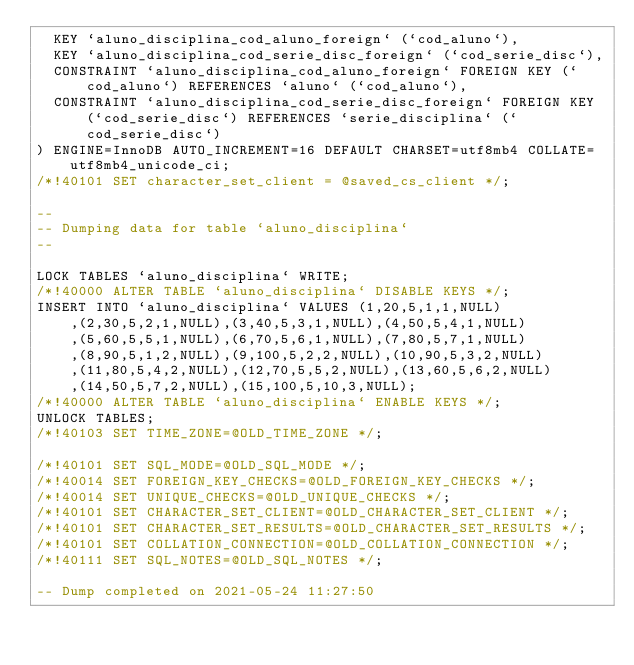<code> <loc_0><loc_0><loc_500><loc_500><_SQL_>  KEY `aluno_disciplina_cod_aluno_foreign` (`cod_aluno`),
  KEY `aluno_disciplina_cod_serie_disc_foreign` (`cod_serie_disc`),
  CONSTRAINT `aluno_disciplina_cod_aluno_foreign` FOREIGN KEY (`cod_aluno`) REFERENCES `aluno` (`cod_aluno`),
  CONSTRAINT `aluno_disciplina_cod_serie_disc_foreign` FOREIGN KEY (`cod_serie_disc`) REFERENCES `serie_disciplina` (`cod_serie_disc`)
) ENGINE=InnoDB AUTO_INCREMENT=16 DEFAULT CHARSET=utf8mb4 COLLATE=utf8mb4_unicode_ci;
/*!40101 SET character_set_client = @saved_cs_client */;

--
-- Dumping data for table `aluno_disciplina`
--

LOCK TABLES `aluno_disciplina` WRITE;
/*!40000 ALTER TABLE `aluno_disciplina` DISABLE KEYS */;
INSERT INTO `aluno_disciplina` VALUES (1,20,5,1,1,NULL),(2,30,5,2,1,NULL),(3,40,5,3,1,NULL),(4,50,5,4,1,NULL),(5,60,5,5,1,NULL),(6,70,5,6,1,NULL),(7,80,5,7,1,NULL),(8,90,5,1,2,NULL),(9,100,5,2,2,NULL),(10,90,5,3,2,NULL),(11,80,5,4,2,NULL),(12,70,5,5,2,NULL),(13,60,5,6,2,NULL),(14,50,5,7,2,NULL),(15,100,5,10,3,NULL);
/*!40000 ALTER TABLE `aluno_disciplina` ENABLE KEYS */;
UNLOCK TABLES;
/*!40103 SET TIME_ZONE=@OLD_TIME_ZONE */;

/*!40101 SET SQL_MODE=@OLD_SQL_MODE */;
/*!40014 SET FOREIGN_KEY_CHECKS=@OLD_FOREIGN_KEY_CHECKS */;
/*!40014 SET UNIQUE_CHECKS=@OLD_UNIQUE_CHECKS */;
/*!40101 SET CHARACTER_SET_CLIENT=@OLD_CHARACTER_SET_CLIENT */;
/*!40101 SET CHARACTER_SET_RESULTS=@OLD_CHARACTER_SET_RESULTS */;
/*!40101 SET COLLATION_CONNECTION=@OLD_COLLATION_CONNECTION */;
/*!40111 SET SQL_NOTES=@OLD_SQL_NOTES */;

-- Dump completed on 2021-05-24 11:27:50
</code> 